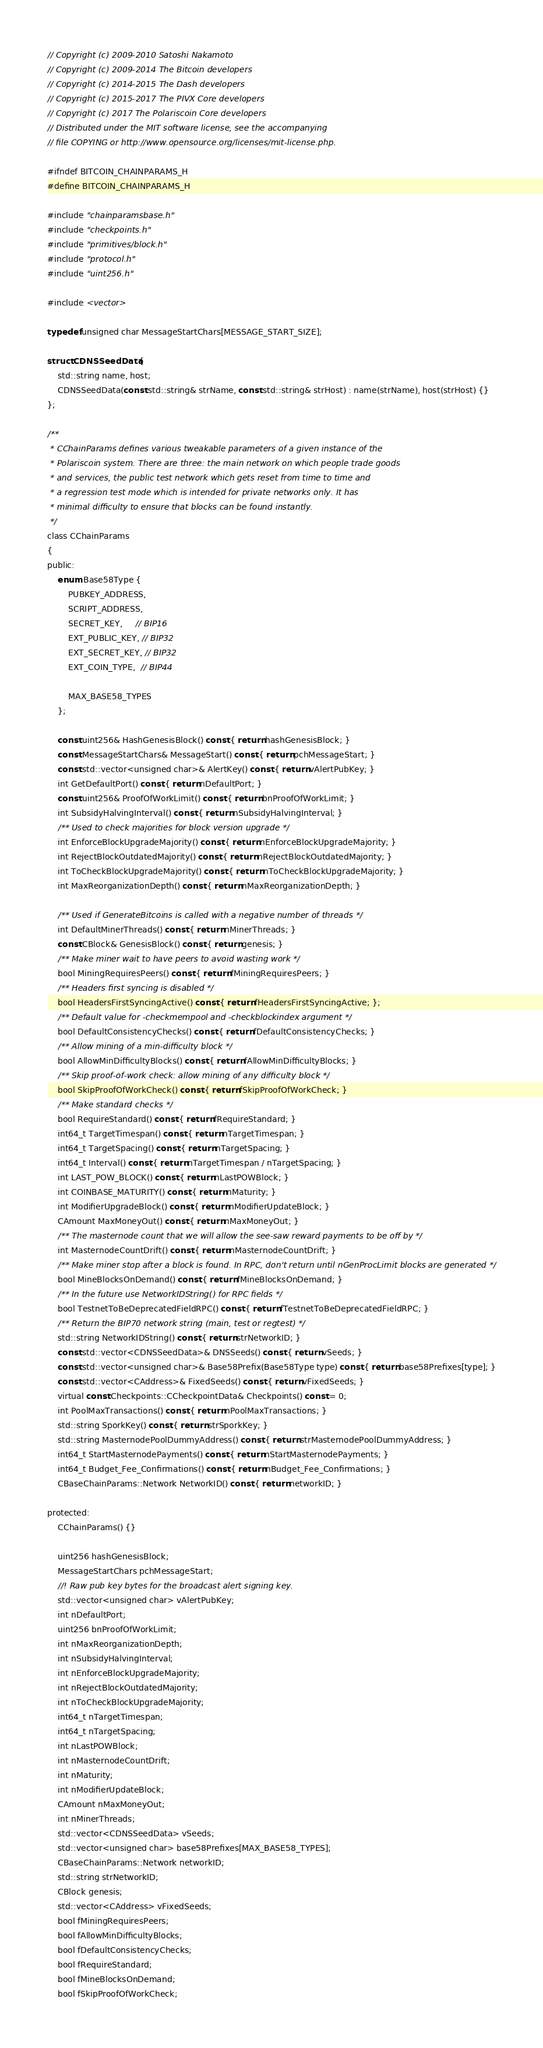Convert code to text. <code><loc_0><loc_0><loc_500><loc_500><_C_>// Copyright (c) 2009-2010 Satoshi Nakamoto
// Copyright (c) 2009-2014 The Bitcoin developers
// Copyright (c) 2014-2015 The Dash developers
// Copyright (c) 2015-2017 The PIVX Core developers
// Copyright (c) 2017 The Polariscoin Core developers
// Distributed under the MIT software license, see the accompanying
// file COPYING or http://www.opensource.org/licenses/mit-license.php.

#ifndef BITCOIN_CHAINPARAMS_H
#define BITCOIN_CHAINPARAMS_H

#include "chainparamsbase.h"
#include "checkpoints.h"
#include "primitives/block.h"
#include "protocol.h"
#include "uint256.h"

#include <vector>

typedef unsigned char MessageStartChars[MESSAGE_START_SIZE];

struct CDNSSeedData {
    std::string name, host;
    CDNSSeedData(const std::string& strName, const std::string& strHost) : name(strName), host(strHost) {}
};

/**
 * CChainParams defines various tweakable parameters of a given instance of the
 * Polariscoin system. There are three: the main network on which people trade goods
 * and services, the public test network which gets reset from time to time and
 * a regression test mode which is intended for private networks only. It has
 * minimal difficulty to ensure that blocks can be found instantly.
 */
class CChainParams
{
public:
    enum Base58Type {
        PUBKEY_ADDRESS,
        SCRIPT_ADDRESS,
        SECRET_KEY,     // BIP16
        EXT_PUBLIC_KEY, // BIP32
        EXT_SECRET_KEY, // BIP32
        EXT_COIN_TYPE,  // BIP44

        MAX_BASE58_TYPES
    };

    const uint256& HashGenesisBlock() const { return hashGenesisBlock; }
    const MessageStartChars& MessageStart() const { return pchMessageStart; }
    const std::vector<unsigned char>& AlertKey() const { return vAlertPubKey; }
    int GetDefaultPort() const { return nDefaultPort; }
    const uint256& ProofOfWorkLimit() const { return bnProofOfWorkLimit; }
    int SubsidyHalvingInterval() const { return nSubsidyHalvingInterval; }
    /** Used to check majorities for block version upgrade */
    int EnforceBlockUpgradeMajority() const { return nEnforceBlockUpgradeMajority; }
    int RejectBlockOutdatedMajority() const { return nRejectBlockOutdatedMajority; }
    int ToCheckBlockUpgradeMajority() const { return nToCheckBlockUpgradeMajority; }
    int MaxReorganizationDepth() const { return nMaxReorganizationDepth; }

    /** Used if GenerateBitcoins is called with a negative number of threads */
    int DefaultMinerThreads() const { return nMinerThreads; }
    const CBlock& GenesisBlock() const { return genesis; }
    /** Make miner wait to have peers to avoid wasting work */
    bool MiningRequiresPeers() const { return fMiningRequiresPeers; }
    /** Headers first syncing is disabled */
    bool HeadersFirstSyncingActive() const { return fHeadersFirstSyncingActive; };
    /** Default value for -checkmempool and -checkblockindex argument */
    bool DefaultConsistencyChecks() const { return fDefaultConsistencyChecks; }
    /** Allow mining of a min-difficulty block */
    bool AllowMinDifficultyBlocks() const { return fAllowMinDifficultyBlocks; }
    /** Skip proof-of-work check: allow mining of any difficulty block */
    bool SkipProofOfWorkCheck() const { return fSkipProofOfWorkCheck; }
    /** Make standard checks */
    bool RequireStandard() const { return fRequireStandard; }
    int64_t TargetTimespan() const { return nTargetTimespan; }
    int64_t TargetSpacing() const { return nTargetSpacing; }
    int64_t Interval() const { return nTargetTimespan / nTargetSpacing; }
    int LAST_POW_BLOCK() const { return nLastPOWBlock; }
    int COINBASE_MATURITY() const { return nMaturity; }
    int ModifierUpgradeBlock() const { return nModifierUpdateBlock; }
    CAmount MaxMoneyOut() const { return nMaxMoneyOut; }
    /** The masternode count that we will allow the see-saw reward payments to be off by */
    int MasternodeCountDrift() const { return nMasternodeCountDrift; }
    /** Make miner stop after a block is found. In RPC, don't return until nGenProcLimit blocks are generated */
    bool MineBlocksOnDemand() const { return fMineBlocksOnDemand; }
    /** In the future use NetworkIDString() for RPC fields */
    bool TestnetToBeDeprecatedFieldRPC() const { return fTestnetToBeDeprecatedFieldRPC; }
    /** Return the BIP70 network string (main, test or regtest) */
    std::string NetworkIDString() const { return strNetworkID; }
    const std::vector<CDNSSeedData>& DNSSeeds() const { return vSeeds; }
    const std::vector<unsigned char>& Base58Prefix(Base58Type type) const { return base58Prefixes[type]; }
    const std::vector<CAddress>& FixedSeeds() const { return vFixedSeeds; }
    virtual const Checkpoints::CCheckpointData& Checkpoints() const = 0;
    int PoolMaxTransactions() const { return nPoolMaxTransactions; }
    std::string SporkKey() const { return strSporkKey; }
    std::string MasternodePoolDummyAddress() const { return strMasternodePoolDummyAddress; }
    int64_t StartMasternodePayments() const { return nStartMasternodePayments; }
    int64_t Budget_Fee_Confirmations() const { return nBudget_Fee_Confirmations; }
    CBaseChainParams::Network NetworkID() const { return networkID; }

protected:
    CChainParams() {}

    uint256 hashGenesisBlock;
    MessageStartChars pchMessageStart;
    //! Raw pub key bytes for the broadcast alert signing key.
    std::vector<unsigned char> vAlertPubKey;
    int nDefaultPort;
    uint256 bnProofOfWorkLimit;
    int nMaxReorganizationDepth;
    int nSubsidyHalvingInterval;
    int nEnforceBlockUpgradeMajority;
    int nRejectBlockOutdatedMajority;
    int nToCheckBlockUpgradeMajority;
    int64_t nTargetTimespan;
    int64_t nTargetSpacing;
    int nLastPOWBlock;
    int nMasternodeCountDrift;
    int nMaturity;
    int nModifierUpdateBlock;
    CAmount nMaxMoneyOut;
    int nMinerThreads;
    std::vector<CDNSSeedData> vSeeds;
    std::vector<unsigned char> base58Prefixes[MAX_BASE58_TYPES];
    CBaseChainParams::Network networkID;
    std::string strNetworkID;
    CBlock genesis;
    std::vector<CAddress> vFixedSeeds;
    bool fMiningRequiresPeers;
    bool fAllowMinDifficultyBlocks;
    bool fDefaultConsistencyChecks;
    bool fRequireStandard;
    bool fMineBlocksOnDemand;
    bool fSkipProofOfWorkCheck;</code> 